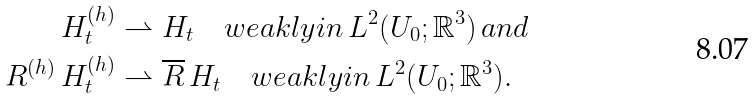<formula> <loc_0><loc_0><loc_500><loc_500>H ^ { ( h ) } _ { t } & \rightharpoonup H _ { t } \quad w e a k l y i n \, L ^ { 2 } ( U _ { 0 } ; \mathbb { R } ^ { 3 } ) \, a n d \\ R ^ { ( h ) } \, H ^ { ( h ) } _ { t } & \rightharpoonup \overline { R } \, H _ { t } \quad w e a k l y i n \, L ^ { 2 } ( U _ { 0 } ; \mathbb { R } ^ { 3 } ) .</formula> 